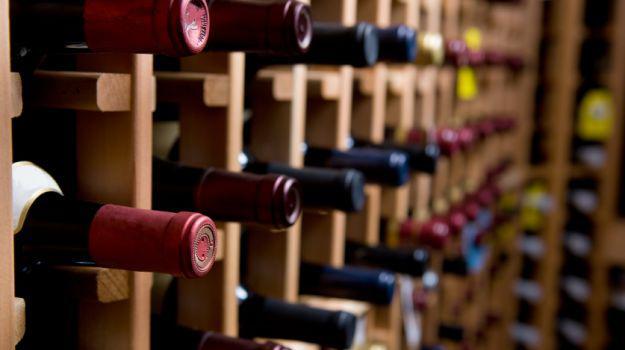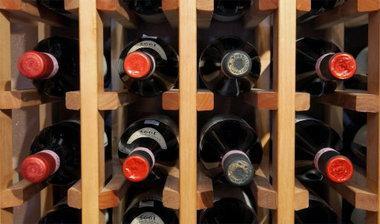The first image is the image on the left, the second image is the image on the right. Examine the images to the left and right. Is the description "At least one image shows wine bottles stored in a rack." accurate? Answer yes or no. Yes. 